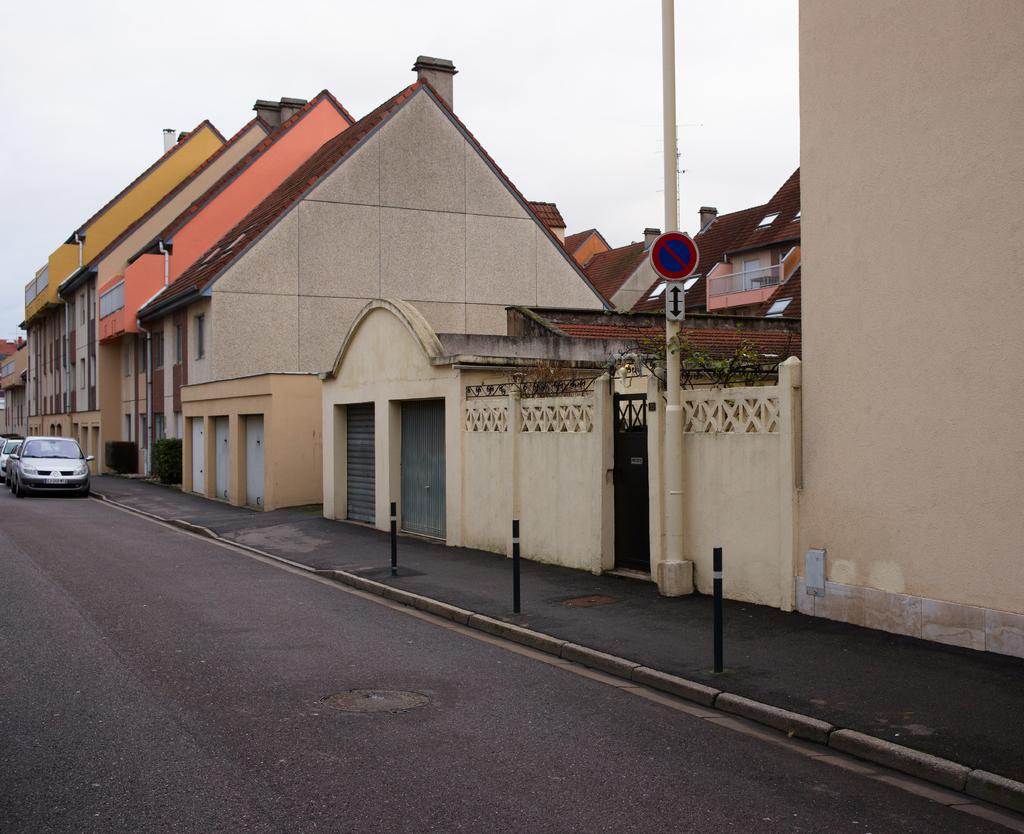What type of vehicles can be seen on the road in the image? There are cars on the road in the image. What celestial bodies are visible in the image? There are planets visible in the image. What type of structures can be seen in the image? There are houses in the image. What object can be seen standing upright in the image? There is a pole in the image. What flat, rectangular object can be seen in the image? There is a board in the image. What is visible in the background of the image? The sky is visible in the background of the image. What texture can be seen on the mother's dress in the image? There is no mother or dress present in the image. What type of work does the secretary do in the image? There is no secretary present in the image. 